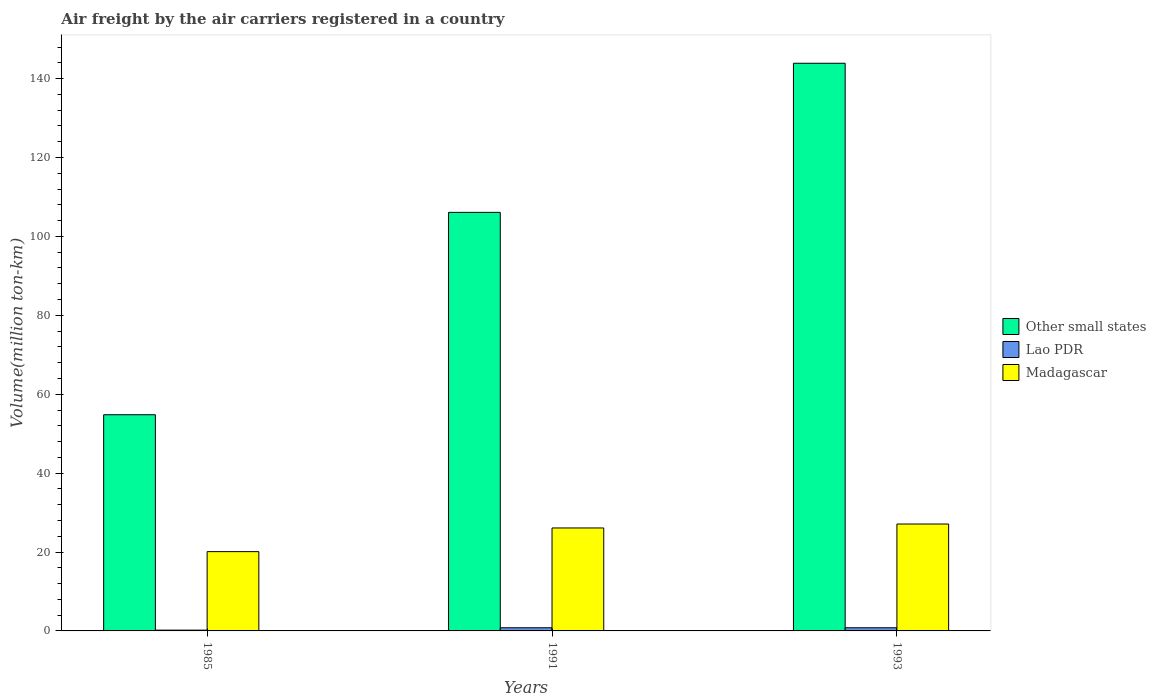How many different coloured bars are there?
Make the answer very short. 3. Are the number of bars on each tick of the X-axis equal?
Ensure brevity in your answer.  Yes. How many bars are there on the 3rd tick from the right?
Offer a very short reply. 3. What is the label of the 2nd group of bars from the left?
Provide a short and direct response. 1991. In how many cases, is the number of bars for a given year not equal to the number of legend labels?
Your answer should be compact. 0. What is the volume of the air carriers in Madagascar in 1993?
Provide a short and direct response. 27.1. Across all years, what is the maximum volume of the air carriers in Madagascar?
Provide a succinct answer. 27.1. Across all years, what is the minimum volume of the air carriers in Other small states?
Your answer should be compact. 54.8. In which year was the volume of the air carriers in Madagascar maximum?
Offer a terse response. 1993. What is the total volume of the air carriers in Madagascar in the graph?
Your response must be concise. 73.3. What is the difference between the volume of the air carriers in Other small states in 1993 and the volume of the air carriers in Lao PDR in 1991?
Give a very brief answer. 143.1. What is the average volume of the air carriers in Madagascar per year?
Offer a terse response. 24.43. In the year 1993, what is the difference between the volume of the air carriers in Other small states and volume of the air carriers in Madagascar?
Give a very brief answer. 116.8. In how many years, is the volume of the air carriers in Lao PDR greater than 124 million ton-km?
Your response must be concise. 0. What is the ratio of the volume of the air carriers in Madagascar in 1991 to that in 1993?
Your answer should be very brief. 0.96. Is the volume of the air carriers in Other small states in 1991 less than that in 1993?
Offer a very short reply. Yes. Is the difference between the volume of the air carriers in Other small states in 1985 and 1991 greater than the difference between the volume of the air carriers in Madagascar in 1985 and 1991?
Keep it short and to the point. No. What is the difference between the highest and the lowest volume of the air carriers in Madagascar?
Your response must be concise. 7. Is the sum of the volume of the air carriers in Other small states in 1985 and 1991 greater than the maximum volume of the air carriers in Madagascar across all years?
Your answer should be compact. Yes. What does the 2nd bar from the left in 1993 represents?
Your response must be concise. Lao PDR. What does the 2nd bar from the right in 1993 represents?
Your answer should be very brief. Lao PDR. How many bars are there?
Offer a very short reply. 9. Are all the bars in the graph horizontal?
Keep it short and to the point. No. Are the values on the major ticks of Y-axis written in scientific E-notation?
Your answer should be very brief. No. Does the graph contain any zero values?
Keep it short and to the point. No. What is the title of the graph?
Make the answer very short. Air freight by the air carriers registered in a country. Does "Sao Tome and Principe" appear as one of the legend labels in the graph?
Make the answer very short. No. What is the label or title of the Y-axis?
Offer a very short reply. Volume(million ton-km). What is the Volume(million ton-km) of Other small states in 1985?
Make the answer very short. 54.8. What is the Volume(million ton-km) in Lao PDR in 1985?
Your response must be concise. 0.2. What is the Volume(million ton-km) in Madagascar in 1985?
Your response must be concise. 20.1. What is the Volume(million ton-km) of Other small states in 1991?
Make the answer very short. 106.1. What is the Volume(million ton-km) in Lao PDR in 1991?
Provide a succinct answer. 0.8. What is the Volume(million ton-km) of Madagascar in 1991?
Provide a short and direct response. 26.1. What is the Volume(million ton-km) in Other small states in 1993?
Your response must be concise. 143.9. What is the Volume(million ton-km) of Lao PDR in 1993?
Your answer should be very brief. 0.8. What is the Volume(million ton-km) in Madagascar in 1993?
Offer a very short reply. 27.1. Across all years, what is the maximum Volume(million ton-km) in Other small states?
Keep it short and to the point. 143.9. Across all years, what is the maximum Volume(million ton-km) in Lao PDR?
Offer a very short reply. 0.8. Across all years, what is the maximum Volume(million ton-km) of Madagascar?
Offer a terse response. 27.1. Across all years, what is the minimum Volume(million ton-km) in Other small states?
Give a very brief answer. 54.8. Across all years, what is the minimum Volume(million ton-km) of Lao PDR?
Keep it short and to the point. 0.2. Across all years, what is the minimum Volume(million ton-km) in Madagascar?
Make the answer very short. 20.1. What is the total Volume(million ton-km) of Other small states in the graph?
Provide a short and direct response. 304.8. What is the total Volume(million ton-km) of Madagascar in the graph?
Make the answer very short. 73.3. What is the difference between the Volume(million ton-km) of Other small states in 1985 and that in 1991?
Your answer should be very brief. -51.3. What is the difference between the Volume(million ton-km) of Lao PDR in 1985 and that in 1991?
Your answer should be very brief. -0.6. What is the difference between the Volume(million ton-km) of Madagascar in 1985 and that in 1991?
Keep it short and to the point. -6. What is the difference between the Volume(million ton-km) in Other small states in 1985 and that in 1993?
Offer a terse response. -89.1. What is the difference between the Volume(million ton-km) in Madagascar in 1985 and that in 1993?
Keep it short and to the point. -7. What is the difference between the Volume(million ton-km) in Other small states in 1991 and that in 1993?
Provide a succinct answer. -37.8. What is the difference between the Volume(million ton-km) of Other small states in 1985 and the Volume(million ton-km) of Lao PDR in 1991?
Your answer should be compact. 54. What is the difference between the Volume(million ton-km) in Other small states in 1985 and the Volume(million ton-km) in Madagascar in 1991?
Provide a short and direct response. 28.7. What is the difference between the Volume(million ton-km) of Lao PDR in 1985 and the Volume(million ton-km) of Madagascar in 1991?
Provide a succinct answer. -25.9. What is the difference between the Volume(million ton-km) of Other small states in 1985 and the Volume(million ton-km) of Lao PDR in 1993?
Offer a very short reply. 54. What is the difference between the Volume(million ton-km) of Other small states in 1985 and the Volume(million ton-km) of Madagascar in 1993?
Make the answer very short. 27.7. What is the difference between the Volume(million ton-km) in Lao PDR in 1985 and the Volume(million ton-km) in Madagascar in 1993?
Give a very brief answer. -26.9. What is the difference between the Volume(million ton-km) in Other small states in 1991 and the Volume(million ton-km) in Lao PDR in 1993?
Your answer should be very brief. 105.3. What is the difference between the Volume(million ton-km) of Other small states in 1991 and the Volume(million ton-km) of Madagascar in 1993?
Provide a short and direct response. 79. What is the difference between the Volume(million ton-km) in Lao PDR in 1991 and the Volume(million ton-km) in Madagascar in 1993?
Provide a short and direct response. -26.3. What is the average Volume(million ton-km) in Other small states per year?
Offer a terse response. 101.6. What is the average Volume(million ton-km) in Lao PDR per year?
Offer a very short reply. 0.6. What is the average Volume(million ton-km) in Madagascar per year?
Offer a very short reply. 24.43. In the year 1985, what is the difference between the Volume(million ton-km) of Other small states and Volume(million ton-km) of Lao PDR?
Your answer should be compact. 54.6. In the year 1985, what is the difference between the Volume(million ton-km) in Other small states and Volume(million ton-km) in Madagascar?
Your response must be concise. 34.7. In the year 1985, what is the difference between the Volume(million ton-km) in Lao PDR and Volume(million ton-km) in Madagascar?
Your answer should be very brief. -19.9. In the year 1991, what is the difference between the Volume(million ton-km) of Other small states and Volume(million ton-km) of Lao PDR?
Keep it short and to the point. 105.3. In the year 1991, what is the difference between the Volume(million ton-km) of Other small states and Volume(million ton-km) of Madagascar?
Ensure brevity in your answer.  80. In the year 1991, what is the difference between the Volume(million ton-km) of Lao PDR and Volume(million ton-km) of Madagascar?
Give a very brief answer. -25.3. In the year 1993, what is the difference between the Volume(million ton-km) of Other small states and Volume(million ton-km) of Lao PDR?
Provide a short and direct response. 143.1. In the year 1993, what is the difference between the Volume(million ton-km) of Other small states and Volume(million ton-km) of Madagascar?
Offer a terse response. 116.8. In the year 1993, what is the difference between the Volume(million ton-km) in Lao PDR and Volume(million ton-km) in Madagascar?
Offer a very short reply. -26.3. What is the ratio of the Volume(million ton-km) of Other small states in 1985 to that in 1991?
Your answer should be very brief. 0.52. What is the ratio of the Volume(million ton-km) in Madagascar in 1985 to that in 1991?
Your answer should be very brief. 0.77. What is the ratio of the Volume(million ton-km) in Other small states in 1985 to that in 1993?
Your answer should be very brief. 0.38. What is the ratio of the Volume(million ton-km) of Madagascar in 1985 to that in 1993?
Ensure brevity in your answer.  0.74. What is the ratio of the Volume(million ton-km) in Other small states in 1991 to that in 1993?
Provide a short and direct response. 0.74. What is the ratio of the Volume(million ton-km) in Lao PDR in 1991 to that in 1993?
Give a very brief answer. 1. What is the ratio of the Volume(million ton-km) in Madagascar in 1991 to that in 1993?
Your answer should be compact. 0.96. What is the difference between the highest and the second highest Volume(million ton-km) in Other small states?
Give a very brief answer. 37.8. What is the difference between the highest and the second highest Volume(million ton-km) in Lao PDR?
Make the answer very short. 0. What is the difference between the highest and the second highest Volume(million ton-km) of Madagascar?
Keep it short and to the point. 1. What is the difference between the highest and the lowest Volume(million ton-km) of Other small states?
Offer a terse response. 89.1. 